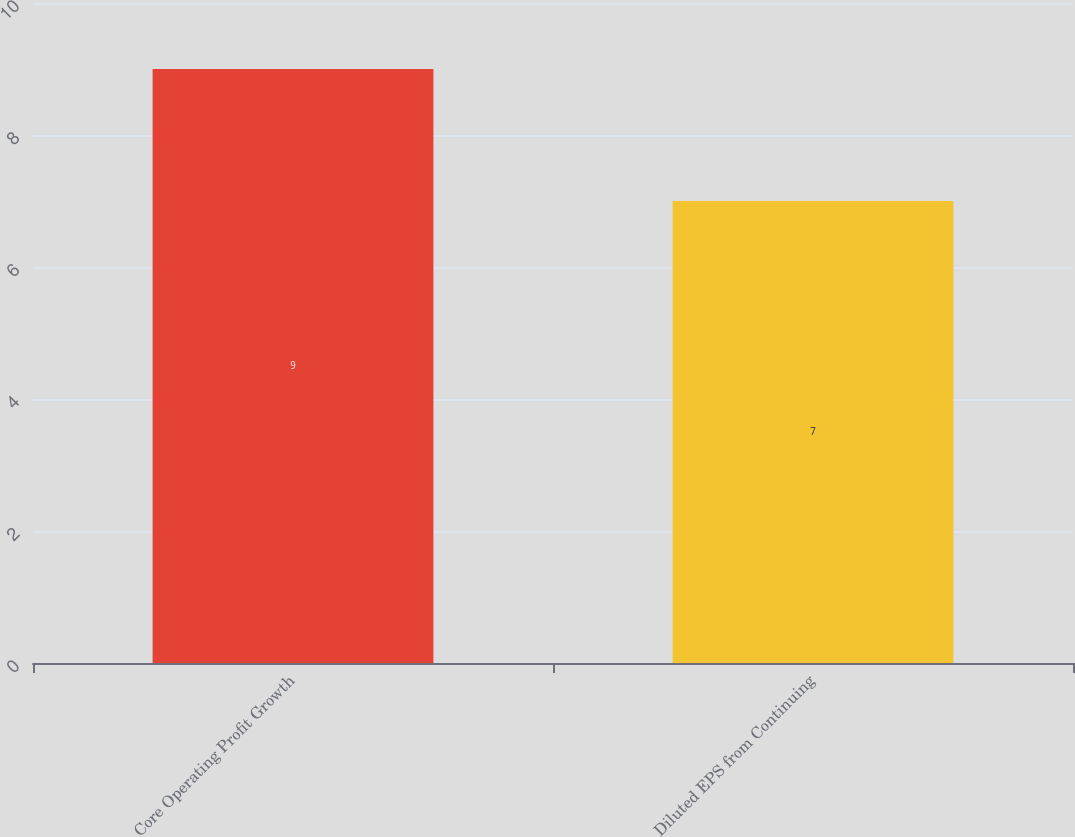Convert chart. <chart><loc_0><loc_0><loc_500><loc_500><bar_chart><fcel>Core Operating Profit Growth<fcel>Diluted EPS from Continuing<nl><fcel>9<fcel>7<nl></chart> 